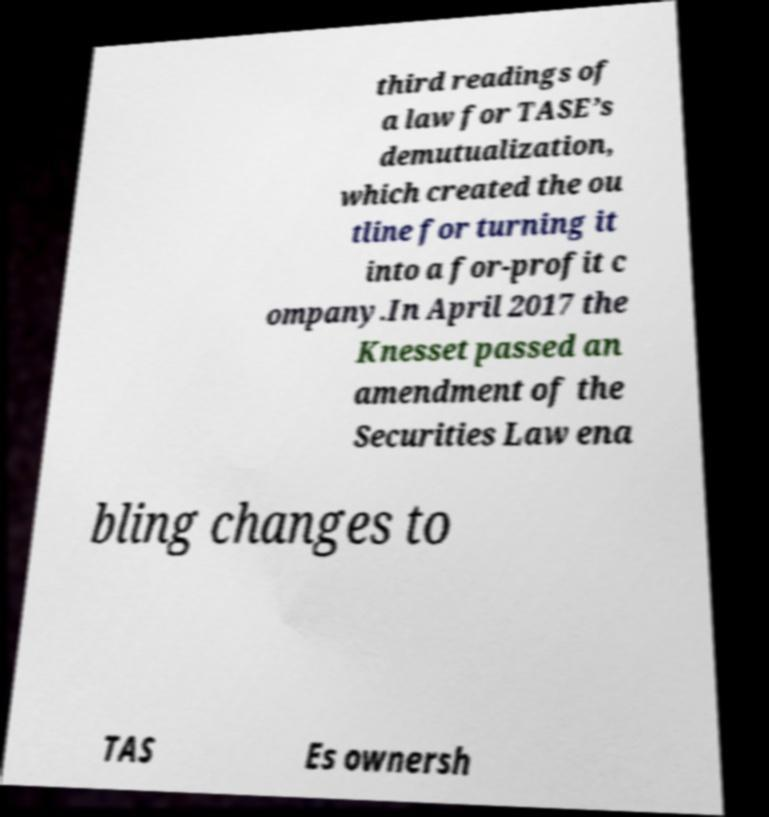What messages or text are displayed in this image? I need them in a readable, typed format. third readings of a law for TASE’s demutualization, which created the ou tline for turning it into a for-profit c ompany.In April 2017 the Knesset passed an amendment of the Securities Law ena bling changes to TAS Es ownersh 